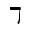<formula> <loc_0><loc_0><loc_500><loc_500>\daleth</formula> 